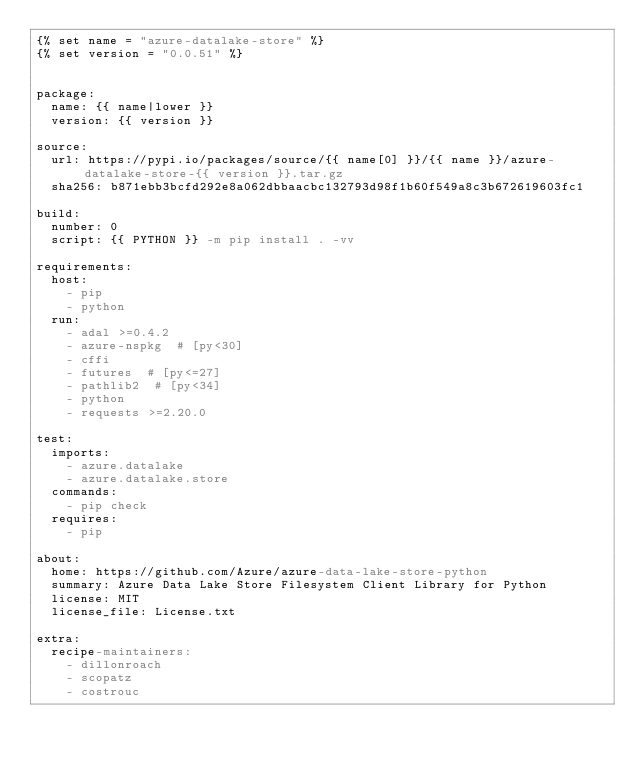Convert code to text. <code><loc_0><loc_0><loc_500><loc_500><_YAML_>{% set name = "azure-datalake-store" %}
{% set version = "0.0.51" %}


package:
  name: {{ name|lower }}
  version: {{ version }}

source:
  url: https://pypi.io/packages/source/{{ name[0] }}/{{ name }}/azure-datalake-store-{{ version }}.tar.gz
  sha256: b871ebb3bcfd292e8a062dbbaacbc132793d98f1b60f549a8c3b672619603fc1

build:
  number: 0
  script: {{ PYTHON }} -m pip install . -vv

requirements:
  host:
    - pip
    - python
  run:
    - adal >=0.4.2
    - azure-nspkg  # [py<30]
    - cffi
    - futures  # [py<=27]
    - pathlib2  # [py<34]
    - python
    - requests >=2.20.0

test:
  imports:
    - azure.datalake
    - azure.datalake.store
  commands:
    - pip check
  requires:
    - pip

about:
  home: https://github.com/Azure/azure-data-lake-store-python
  summary: Azure Data Lake Store Filesystem Client Library for Python
  license: MIT
  license_file: License.txt

extra:
  recipe-maintainers:
    - dillonroach
    - scopatz
    - costrouc
</code> 